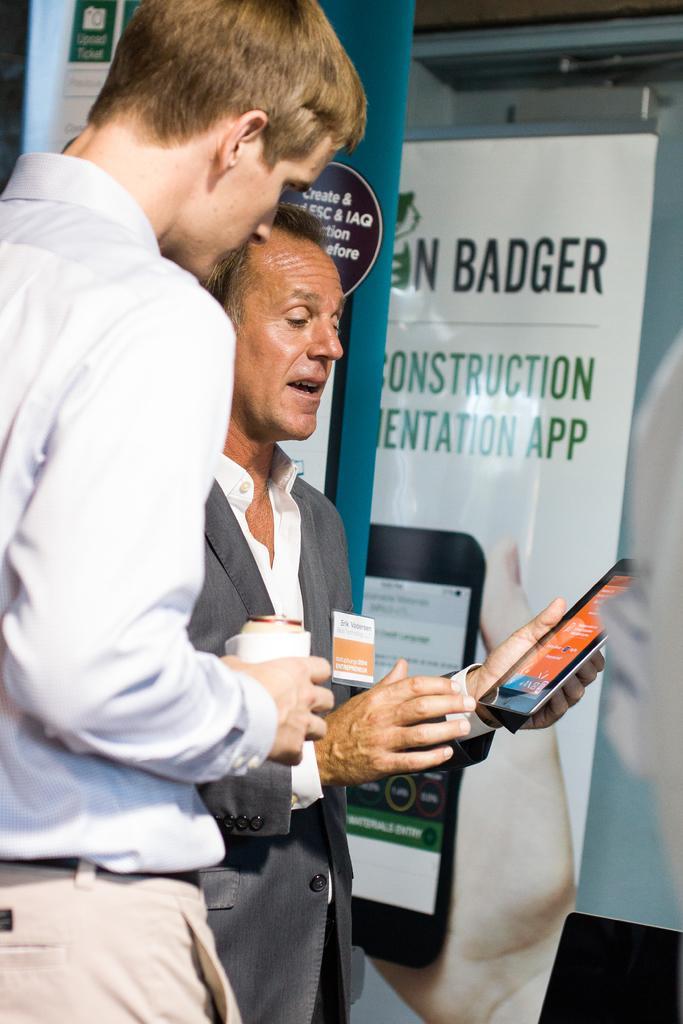Please provide a concise description of this image. This image consists of two persons. On the left, the man is wearing a white shirt. Beside him, the man is wearing a suit and holding a tablet in his hand. In the background, there are banners. 